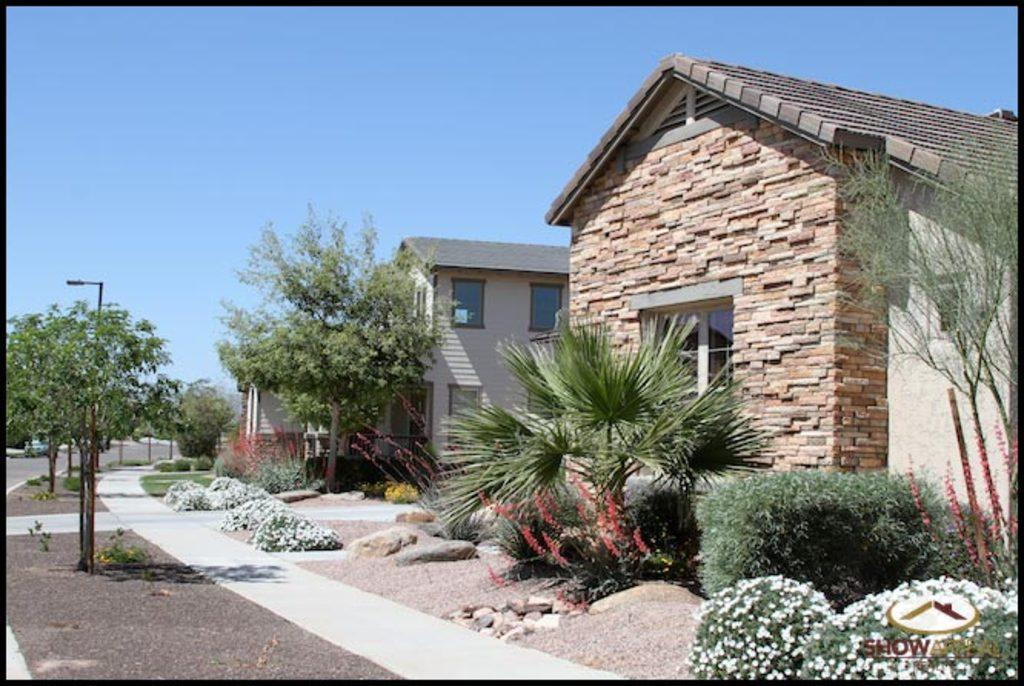What type of vegetation can be seen on the left side of the image? There are trees on the left side of the image. What structure is also present on the left side of the image? There is a pole on the left side of the image. What type of path is visible on the right side of the image? There is a footpath on the right side of the image. What type of vegetation can be seen on the right side of the image? There are plants on the right side of the image. What type of man-made structures are visible on the right side of the image? There are buildings on the right side of the image. What color is the sky in the background of the image? The sky is blue in the background of the image. How many butter bubbles can be seen floating in the sky in the image? There are no butter bubbles present in the image; the sky is blue in the background. What type of balance is required to walk on the footpath in the image? The image does not show anyone walking on the footpath, so it is not possible to determine the type of balance required. 